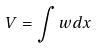<formula> <loc_0><loc_0><loc_500><loc_500>V = \int w d x</formula> 